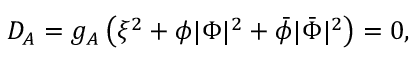<formula> <loc_0><loc_0><loc_500><loc_500>D _ { A } = g _ { A } \left ( \xi ^ { 2 } + \phi | \Phi | ^ { 2 } + \bar { \phi } | \bar { \Phi } | ^ { 2 } \right ) = 0 ,</formula> 